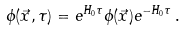<formula> <loc_0><loc_0><loc_500><loc_500>\phi ( \vec { x } , \tau ) = e ^ { H _ { 0 } \tau } \phi ( \vec { x } ) e ^ { - H _ { 0 } \tau } \, .</formula> 